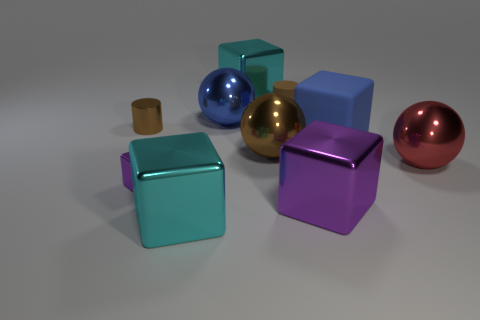How many metal balls have the same color as the small rubber cylinder? Among the objects present, one metal ball shares the same color as the small rubber cylinder. This ball has a reflective surface that distinguishes it from the matte appearance of the rubber cylinder. Both items exhibit a similar shade of brownish coloration, affirming that there is only one metal ball matching the cylinder's color. 